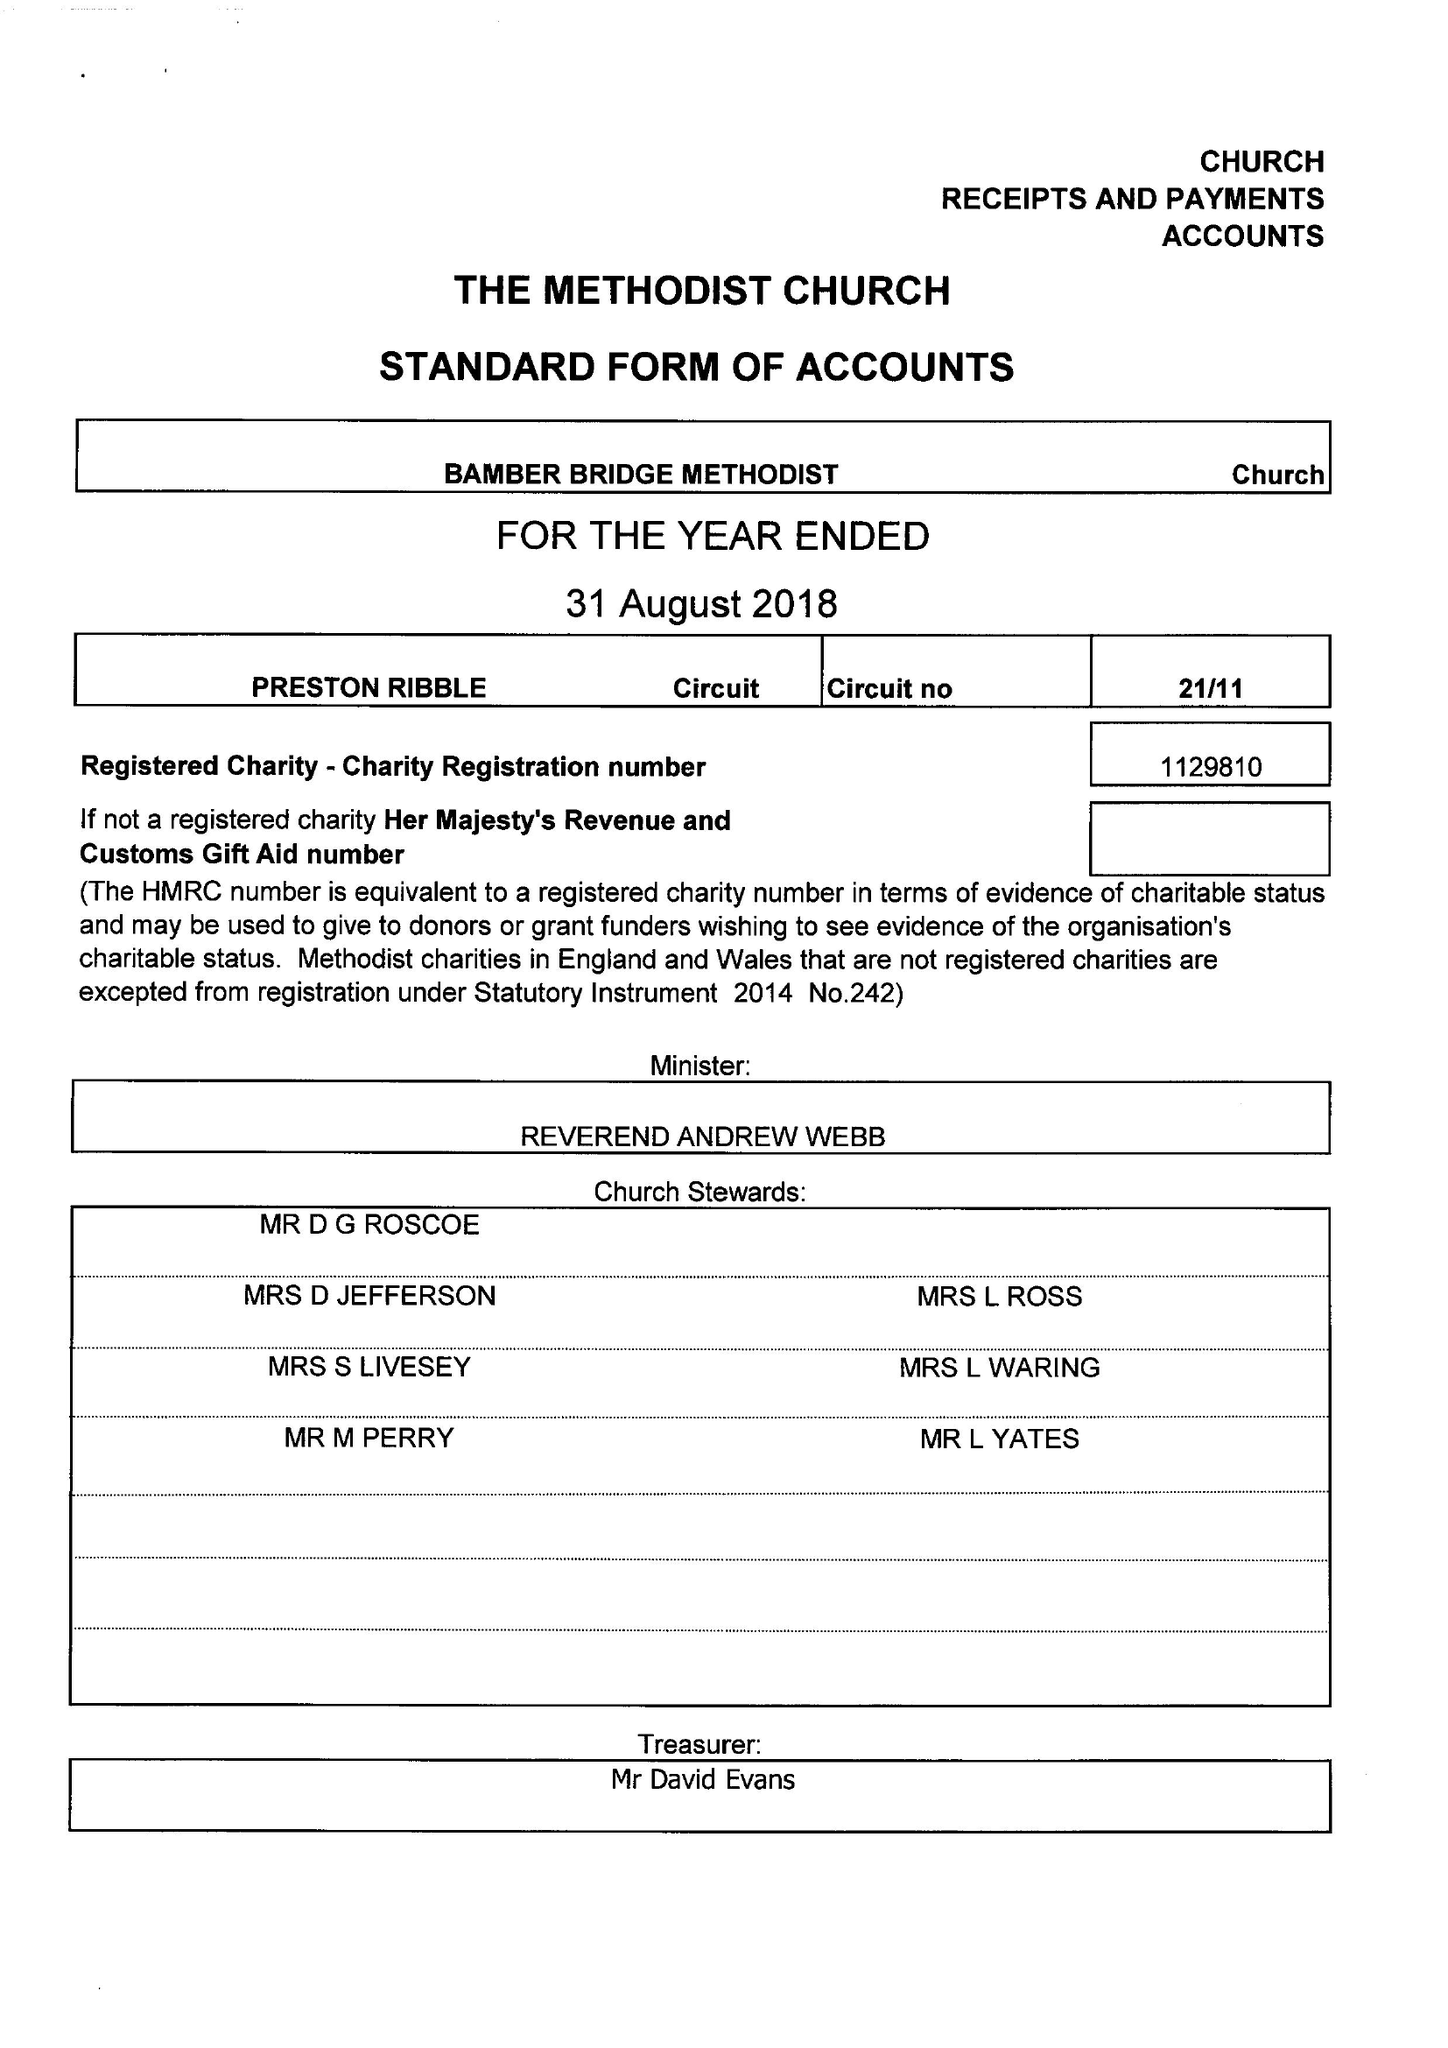What is the value for the address__postcode?
Answer the question using a single word or phrase. PR5 6FB 